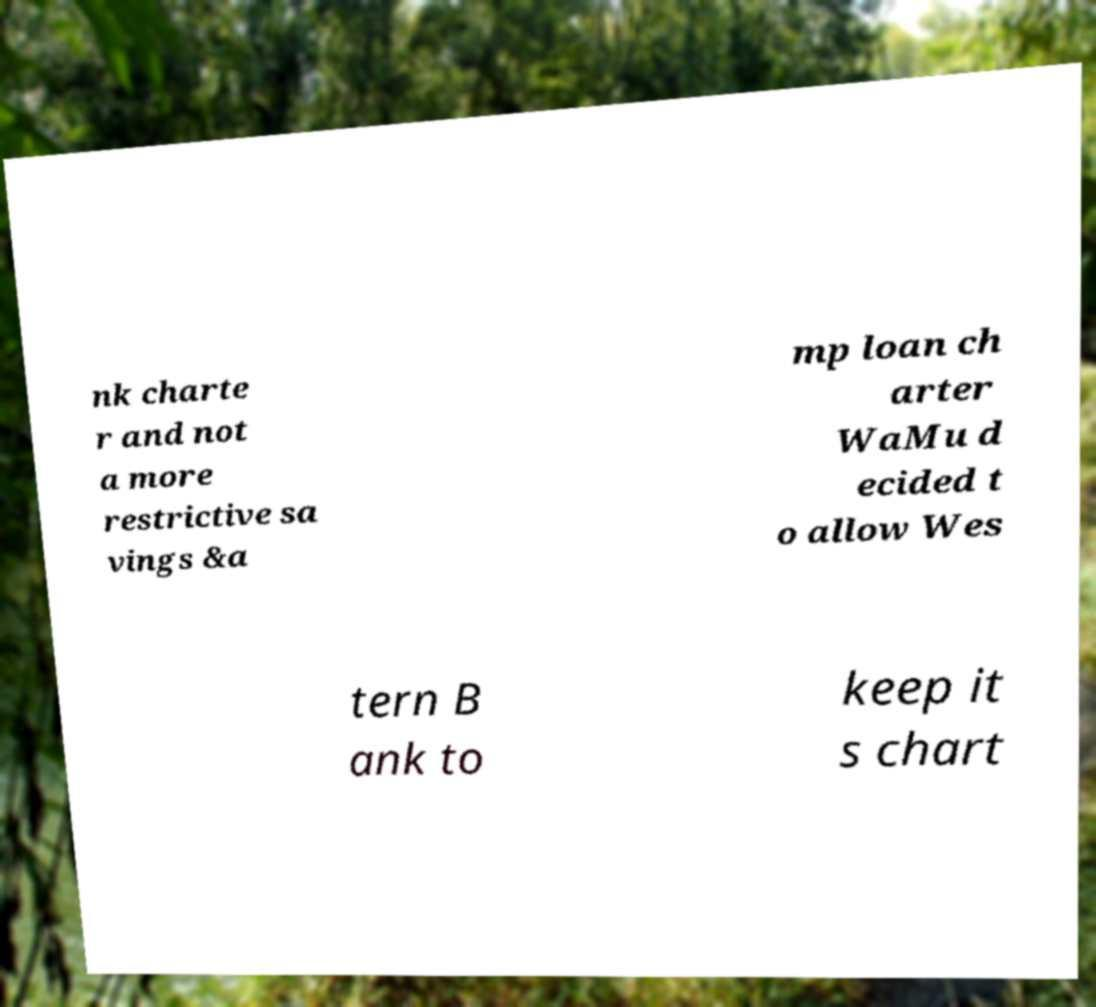Could you assist in decoding the text presented in this image and type it out clearly? nk charte r and not a more restrictive sa vings &a mp loan ch arter WaMu d ecided t o allow Wes tern B ank to keep it s chart 